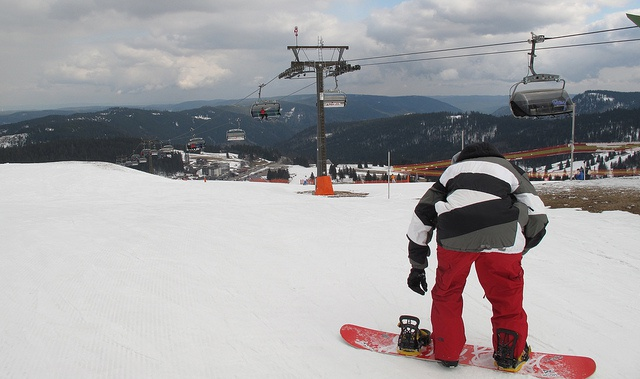Describe the objects in this image and their specific colors. I can see people in darkgray, black, brown, maroon, and gray tones, snowboard in darkgray, brown, black, and maroon tones, people in darkgray, black, gray, brown, and maroon tones, and people in darkgray, maroon, brown, gray, and black tones in this image. 